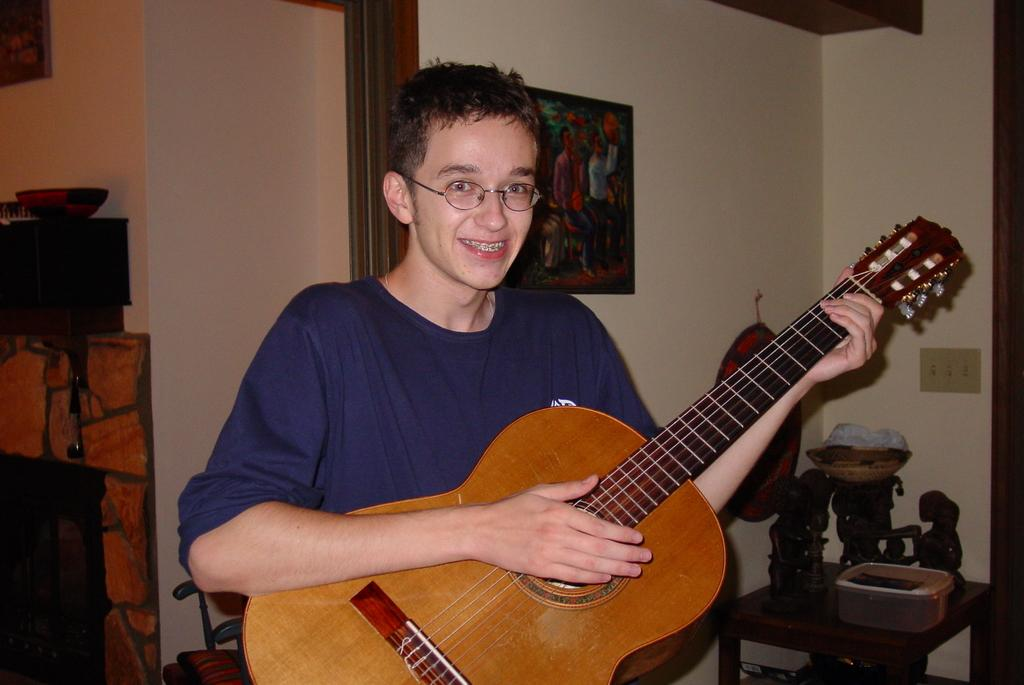Who is the main subject in the image? There is a boy in the image. What is the boy doing in the image? The boy is playing a guitar. Can you describe the setting of the image? The setting appears to be a living room. What else can be seen in the image besides the boy and the guitar? There is a painting visible in the image. What news is the boy sharing with the ants in the image? There are no ants present in the image, and the boy is not sharing any news. 